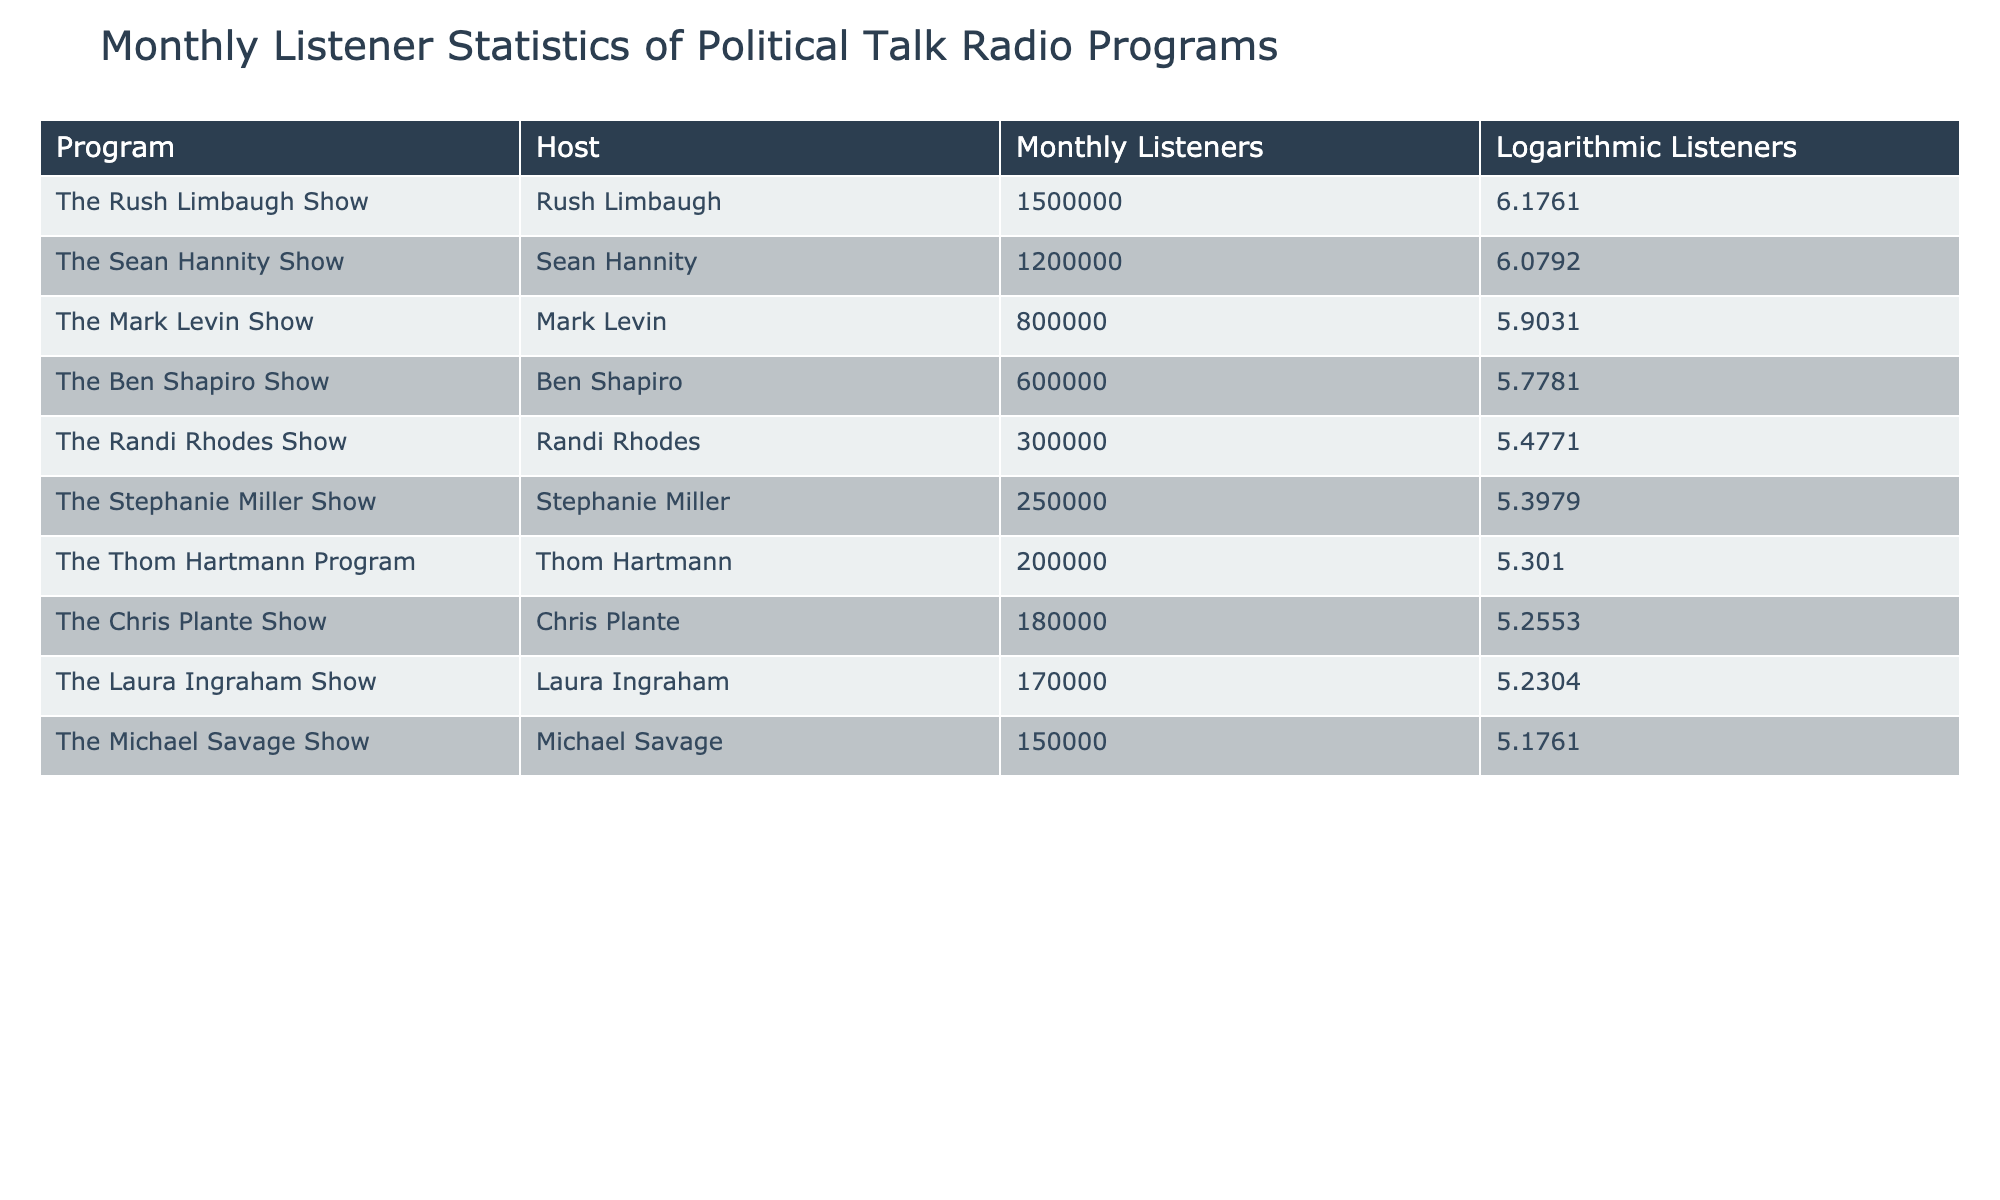What is the program with the highest number of monthly listeners? The highest number of monthly listeners is found in the row of "The Rush Limbaugh Show," which has 1,500,000 listeners.
Answer: The Rush Limbaugh Show What are the logarithmic values for the two programs with the lowest monthly listeners? The programs with the lowest monthly listeners are "The Thom Hartmann Program" with 200,000 listeners and "The Stephanie Miller Show" with 250,000 listeners, which have logarithmic values of 5.3010 and 5.3979, respectively.
Answer: 5.3010 and 5.3979 How many more listeners does "The Sean Hannity Show" have compared to "The Michael Savage Show"? "The Sean Hannity Show" has 1,200,000 listeners and "The Michael Savage Show" has 150,000 listeners. The difference is calculated as 1,200,000 - 150,000 = 1,050,000.
Answer: 1,050,000 Is the logarithmic value of "The Ben Shapiro Show" greater than that of "The Mark Levin Show"? The logarithmic value for "The Ben Shapiro Show" is 5.7781, and for "The Mark Levin Show," it's 5.9031. Since 5.7781 is less than 5.9031, the statement is false.
Answer: No What is the average number of monthly listeners for the top 3 programs? The top 3 programs are "The Rush Limbaugh Show" (1,500,000), "The Sean Hannity Show" (1,200,000), and "The Mark Levin Show" (800,000). The sum of these listeners is 1,500,000 + 1,200,000 + 800,000 = 3,500,000. The average is 3,500,000 divided by 3, which equals approximately 1,166,667.
Answer: 1,166,667 Which program has a lower logarithmic value: "The Laura Ingraham Show" or "The Chris Plante Show"? The logarithmic value for "The Laura Ingraham Show" is 5.2304 and for "The Chris Plante Show" it's 5.2553. Since 5.2304 is less than 5.2553, "The Laura Ingraham Show" has the lower value.
Answer: The Laura Ingraham Show How many programs have monthly listeners greater than 500,000? The programs with monthly listeners greater than 500,000 are "The Rush Limbaugh Show," "The Sean Hannity Show," and "The Mark Levin Show." Counting these gives us a total of 3 programs exceeding that listener count.
Answer: 3 Is the total number of monthly listeners for all programs greater than 4 million? The total monthly listeners can be calculated by adding all the listeners from each program, which equals 1500000 + 1200000 + 800000 + 600000 + 300000 + 250000 + 200000 + 180000 + 170000 + 150000 = 4,300,000. Since 4,300,000 is greater than 4 million, the answer is yes.
Answer: Yes 